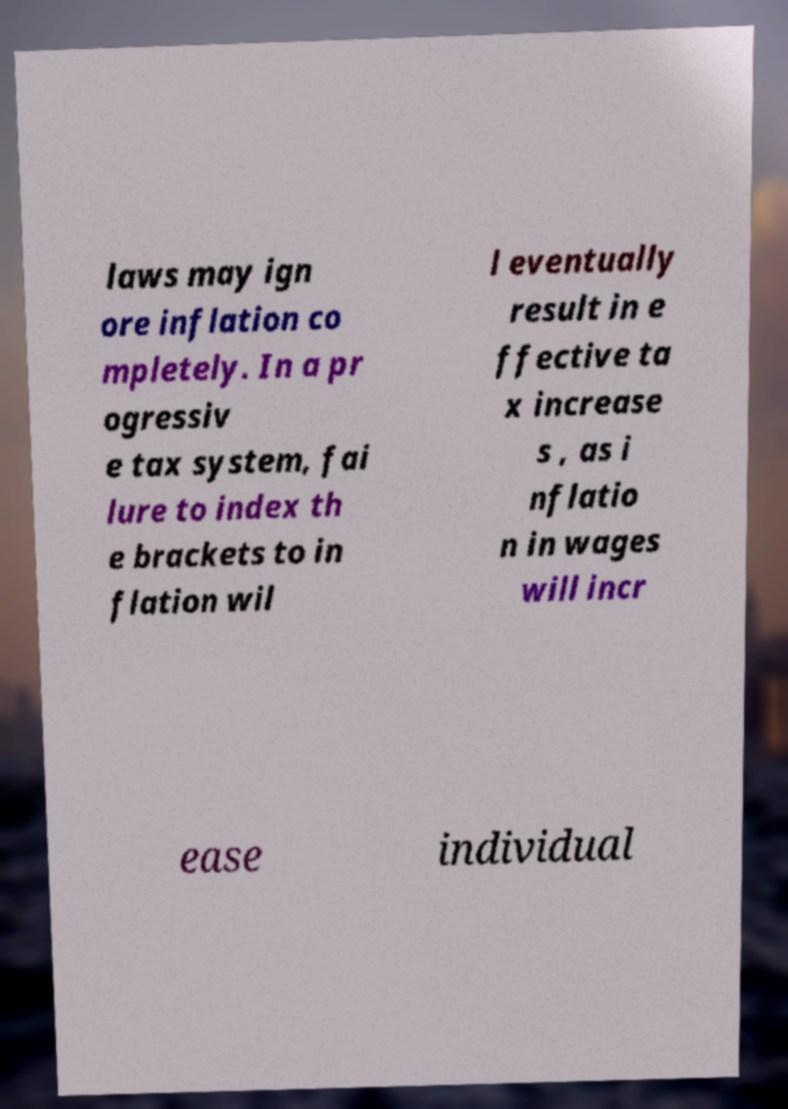Could you assist in decoding the text presented in this image and type it out clearly? laws may ign ore inflation co mpletely. In a pr ogressiv e tax system, fai lure to index th e brackets to in flation wil l eventually result in e ffective ta x increase s , as i nflatio n in wages will incr ease individual 